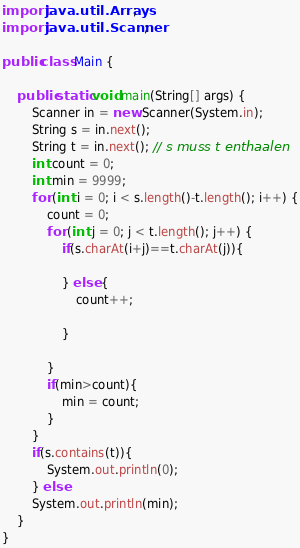<code> <loc_0><loc_0><loc_500><loc_500><_Java_>
import java.util.Arrays;
import java.util.Scanner;

public class Main {

    public static void main(String[] args) {
        Scanner in = new Scanner(System.in);
        String s = in.next();
        String t = in.next(); // s muss t enthaalen
        int count = 0;
        int min = 9999;
        for (int i = 0; i < s.length()-t.length(); i++) {
            count = 0;
            for (int j = 0; j < t.length(); j++) {
                if(s.charAt(i+j)==t.charAt(j)){
                    
                } else {
                    count++;
                    
                }
   
            }
            if(min>count){
                min = count;
            }
        }
        if(s.contains(t)){
            System.out.println(0);
        } else
        System.out.println(min);
    }
}
</code> 